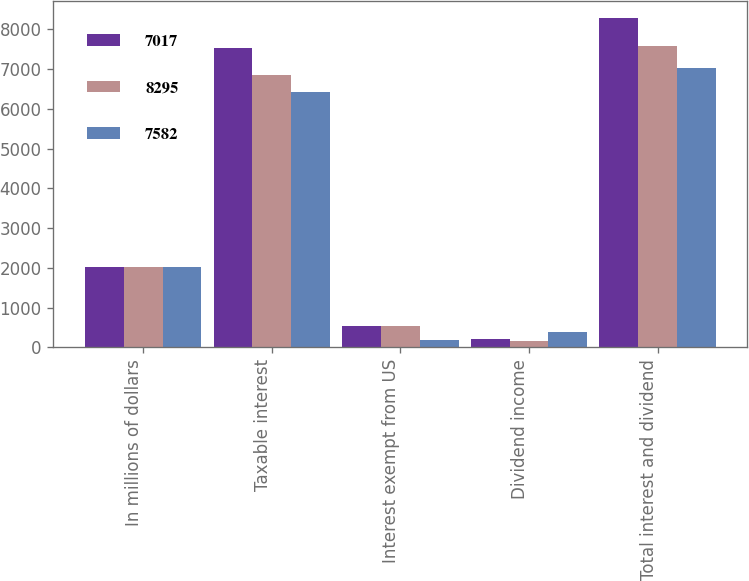Convert chart. <chart><loc_0><loc_0><loc_500><loc_500><stacked_bar_chart><ecel><fcel>In millions of dollars<fcel>Taxable interest<fcel>Interest exempt from US<fcel>Dividend income<fcel>Total interest and dividend<nl><fcel>7017<fcel>2017<fcel>7538<fcel>535<fcel>222<fcel>8295<nl><fcel>8295<fcel>2016<fcel>6858<fcel>549<fcel>175<fcel>7582<nl><fcel>7582<fcel>2015<fcel>6433<fcel>196<fcel>388<fcel>7017<nl></chart> 